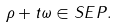Convert formula to latex. <formula><loc_0><loc_0><loc_500><loc_500>\rho + t \omega \in S E P .</formula> 